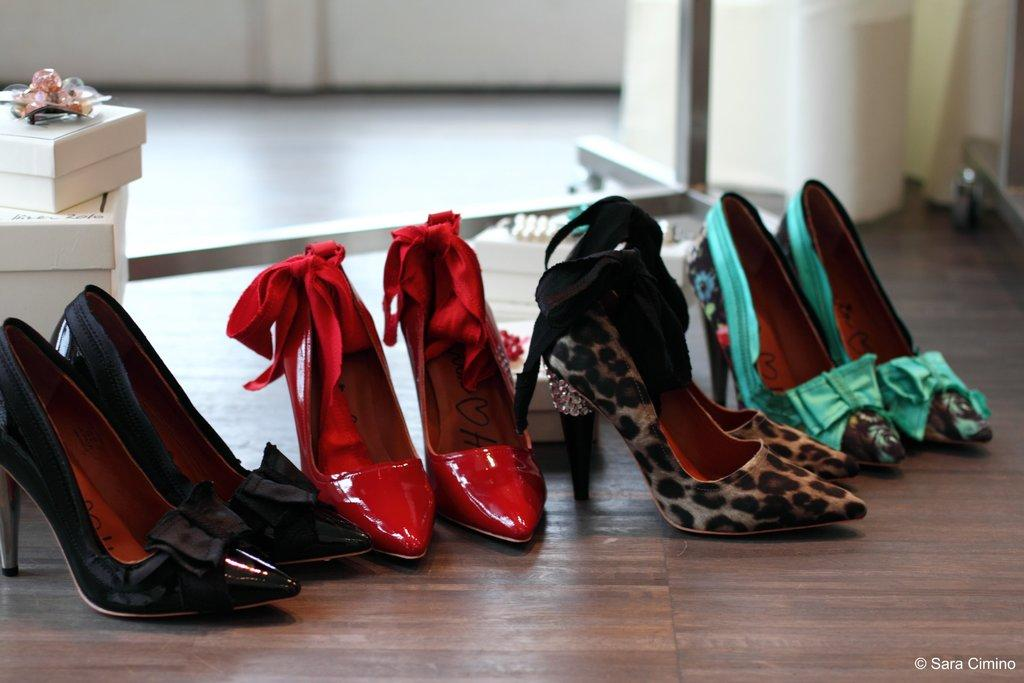What type of objects can be seen in the image? There are boxes in the image. What else can be seen in the image besides the boxes? There are different colors of sandals and objects on a surface in the image. What is visible in the background of the image? There is a wall visible in the background of the image. What type of honey can be seen dripping from the roof in the image? There is no honey or roof present in the image. Can you describe the cat sitting on the boxes in the image? There is no cat present in the image; only boxes, sandals, and objects on a surface are visible. 